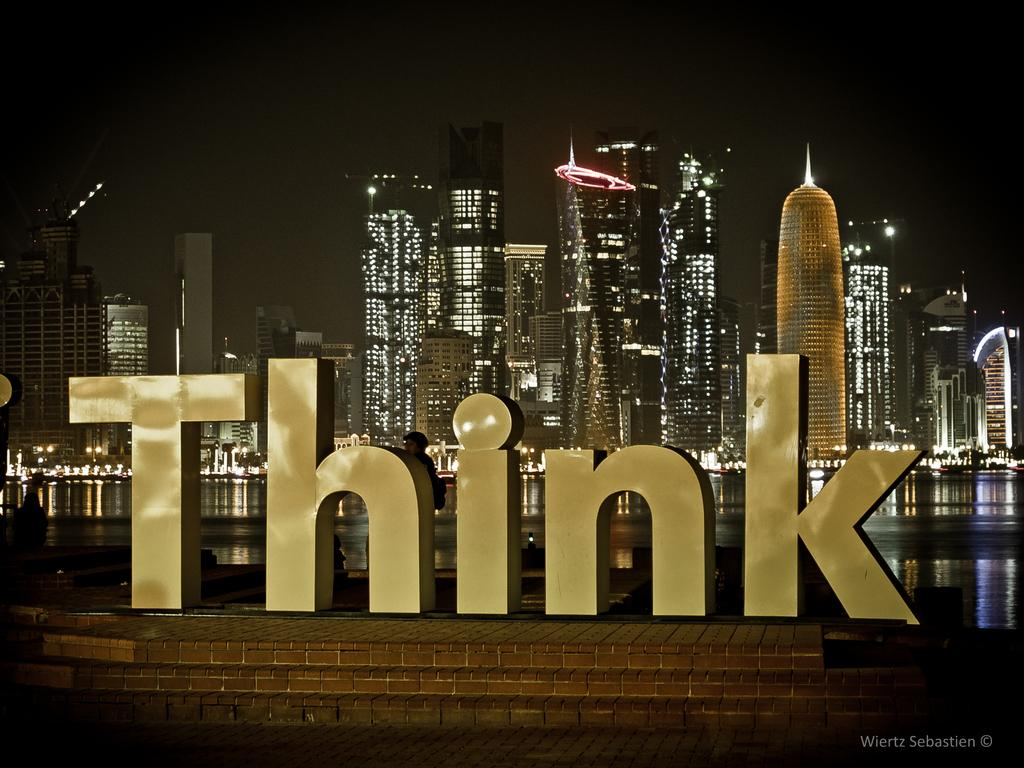What can be seen in the foreground of the image? There are alphabet emblems in the foreground of the image. What is visible in the middle of the image? There is a water surface visible in the image. What type of structures are located behind the water surface in the image? There are buildings behind the water surface in the image. Reasoning: Let's think step by step by breaking down the image into its main components. We start with the foreground, where we find the alphabet emblems. Then, we move to the middle of the image, where we see the water surface. Finally, we focus on the background, which features buildings. By following this structure, we can create a conversation that accurately describes the image without making any assumptions or asking questions that cannot be answered definitively. Absurd Question/Answer: What type of leaf is falling from the curtain in the image? There is no leaf or curtain present in the image. 